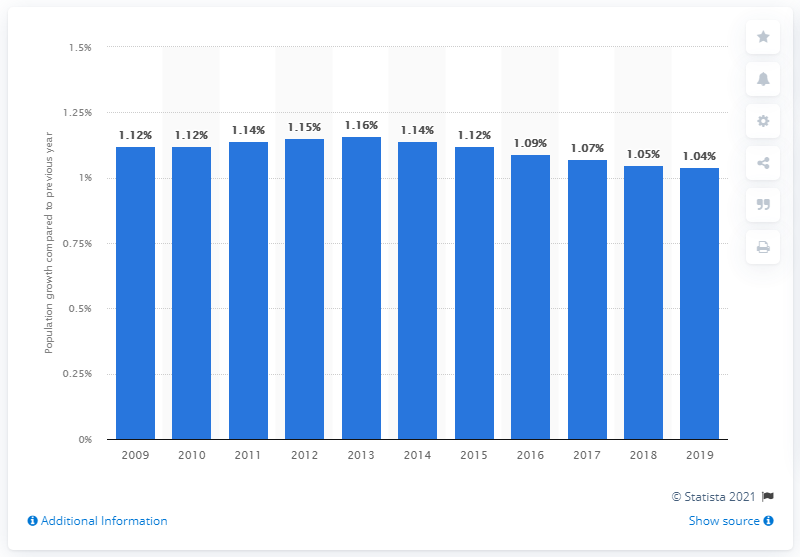Outline some significant characteristics in this image. According to the data, the Bangladeshi population increased by 1.04% in 2019. 